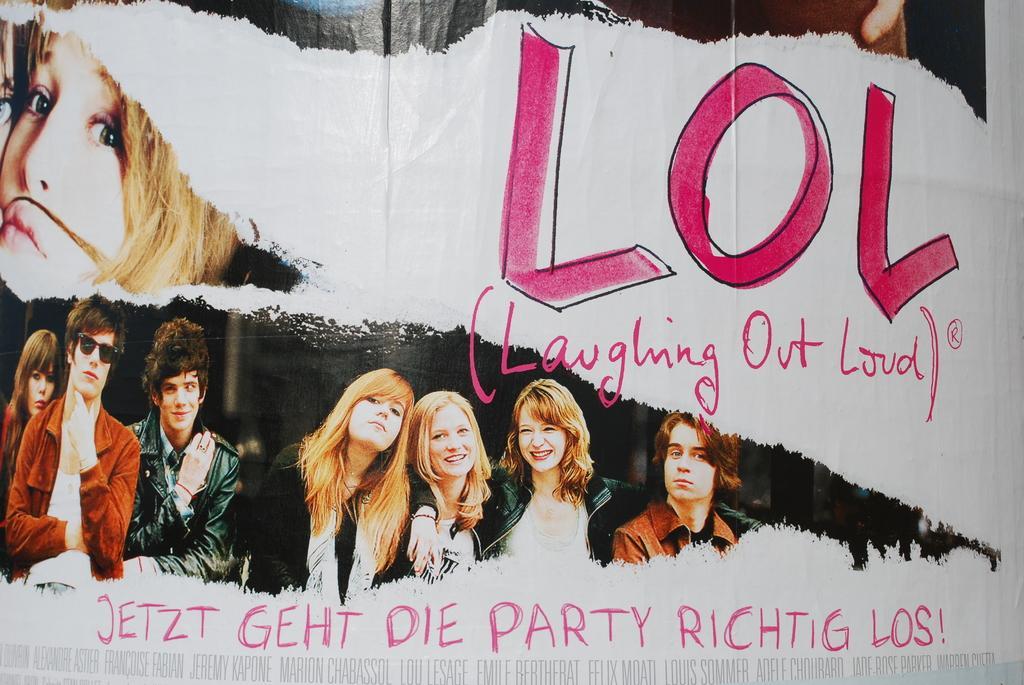In one or two sentences, can you explain what this image depicts? In this image there is a banner. There are pictures of a few people and text on the banner. 